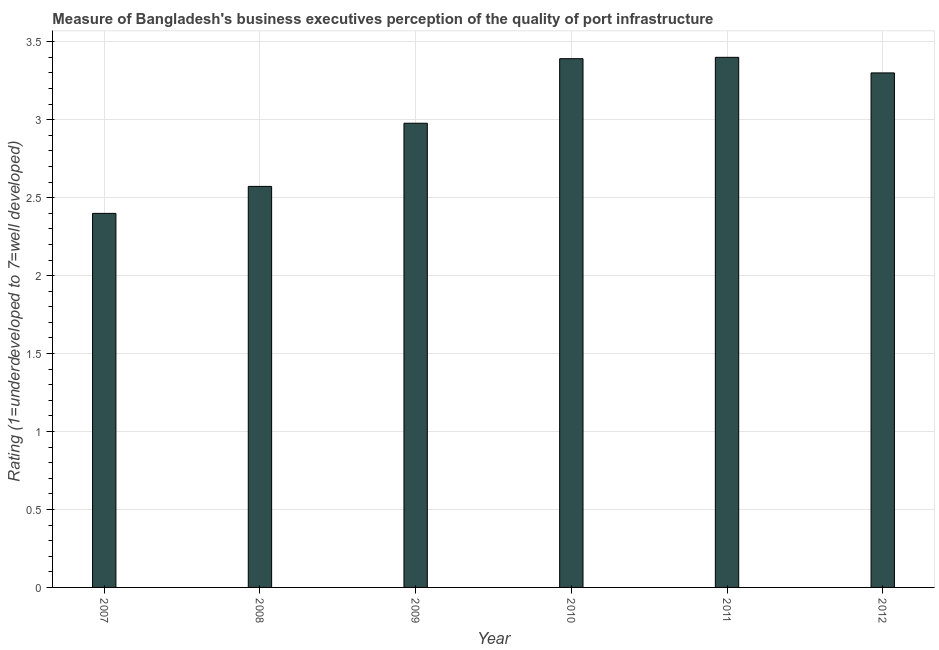Does the graph contain any zero values?
Offer a terse response. No. Does the graph contain grids?
Your answer should be compact. Yes. What is the title of the graph?
Provide a short and direct response. Measure of Bangladesh's business executives perception of the quality of port infrastructure. What is the label or title of the X-axis?
Provide a short and direct response. Year. What is the label or title of the Y-axis?
Offer a very short reply. Rating (1=underdeveloped to 7=well developed) . Across all years, what is the maximum rating measuring quality of port infrastructure?
Give a very brief answer. 3.4. Across all years, what is the minimum rating measuring quality of port infrastructure?
Offer a very short reply. 2.4. In which year was the rating measuring quality of port infrastructure maximum?
Your answer should be very brief. 2011. In which year was the rating measuring quality of port infrastructure minimum?
Your answer should be compact. 2007. What is the sum of the rating measuring quality of port infrastructure?
Your answer should be very brief. 18.04. What is the difference between the rating measuring quality of port infrastructure in 2007 and 2009?
Provide a succinct answer. -0.58. What is the average rating measuring quality of port infrastructure per year?
Your response must be concise. 3.01. What is the median rating measuring quality of port infrastructure?
Offer a very short reply. 3.14. In how many years, is the rating measuring quality of port infrastructure greater than 2.4 ?
Offer a terse response. 5. What is the ratio of the rating measuring quality of port infrastructure in 2009 to that in 2010?
Your answer should be compact. 0.88. Is the rating measuring quality of port infrastructure in 2008 less than that in 2009?
Make the answer very short. Yes. What is the difference between the highest and the second highest rating measuring quality of port infrastructure?
Provide a succinct answer. 0.01. How many bars are there?
Provide a short and direct response. 6. Are the values on the major ticks of Y-axis written in scientific E-notation?
Provide a short and direct response. No. What is the Rating (1=underdeveloped to 7=well developed)  in 2007?
Your answer should be very brief. 2.4. What is the Rating (1=underdeveloped to 7=well developed)  of 2008?
Provide a short and direct response. 2.57. What is the Rating (1=underdeveloped to 7=well developed)  of 2009?
Ensure brevity in your answer.  2.98. What is the Rating (1=underdeveloped to 7=well developed)  in 2010?
Make the answer very short. 3.39. What is the Rating (1=underdeveloped to 7=well developed)  in 2011?
Offer a very short reply. 3.4. What is the Rating (1=underdeveloped to 7=well developed)  in 2012?
Provide a succinct answer. 3.3. What is the difference between the Rating (1=underdeveloped to 7=well developed)  in 2007 and 2008?
Your answer should be very brief. -0.17. What is the difference between the Rating (1=underdeveloped to 7=well developed)  in 2007 and 2009?
Your response must be concise. -0.58. What is the difference between the Rating (1=underdeveloped to 7=well developed)  in 2007 and 2010?
Give a very brief answer. -0.99. What is the difference between the Rating (1=underdeveloped to 7=well developed)  in 2007 and 2011?
Provide a succinct answer. -1. What is the difference between the Rating (1=underdeveloped to 7=well developed)  in 2007 and 2012?
Provide a short and direct response. -0.9. What is the difference between the Rating (1=underdeveloped to 7=well developed)  in 2008 and 2009?
Your response must be concise. -0.41. What is the difference between the Rating (1=underdeveloped to 7=well developed)  in 2008 and 2010?
Offer a very short reply. -0.82. What is the difference between the Rating (1=underdeveloped to 7=well developed)  in 2008 and 2011?
Give a very brief answer. -0.83. What is the difference between the Rating (1=underdeveloped to 7=well developed)  in 2008 and 2012?
Your answer should be compact. -0.73. What is the difference between the Rating (1=underdeveloped to 7=well developed)  in 2009 and 2010?
Ensure brevity in your answer.  -0.41. What is the difference between the Rating (1=underdeveloped to 7=well developed)  in 2009 and 2011?
Your response must be concise. -0.42. What is the difference between the Rating (1=underdeveloped to 7=well developed)  in 2009 and 2012?
Your response must be concise. -0.32. What is the difference between the Rating (1=underdeveloped to 7=well developed)  in 2010 and 2011?
Provide a succinct answer. -0.01. What is the difference between the Rating (1=underdeveloped to 7=well developed)  in 2010 and 2012?
Offer a very short reply. 0.09. What is the difference between the Rating (1=underdeveloped to 7=well developed)  in 2011 and 2012?
Keep it short and to the point. 0.1. What is the ratio of the Rating (1=underdeveloped to 7=well developed)  in 2007 to that in 2008?
Your response must be concise. 0.93. What is the ratio of the Rating (1=underdeveloped to 7=well developed)  in 2007 to that in 2009?
Your response must be concise. 0.81. What is the ratio of the Rating (1=underdeveloped to 7=well developed)  in 2007 to that in 2010?
Provide a succinct answer. 0.71. What is the ratio of the Rating (1=underdeveloped to 7=well developed)  in 2007 to that in 2011?
Keep it short and to the point. 0.71. What is the ratio of the Rating (1=underdeveloped to 7=well developed)  in 2007 to that in 2012?
Keep it short and to the point. 0.73. What is the ratio of the Rating (1=underdeveloped to 7=well developed)  in 2008 to that in 2009?
Give a very brief answer. 0.86. What is the ratio of the Rating (1=underdeveloped to 7=well developed)  in 2008 to that in 2010?
Your answer should be very brief. 0.76. What is the ratio of the Rating (1=underdeveloped to 7=well developed)  in 2008 to that in 2011?
Your response must be concise. 0.76. What is the ratio of the Rating (1=underdeveloped to 7=well developed)  in 2008 to that in 2012?
Provide a succinct answer. 0.78. What is the ratio of the Rating (1=underdeveloped to 7=well developed)  in 2009 to that in 2010?
Your answer should be very brief. 0.88. What is the ratio of the Rating (1=underdeveloped to 7=well developed)  in 2009 to that in 2011?
Provide a short and direct response. 0.88. What is the ratio of the Rating (1=underdeveloped to 7=well developed)  in 2009 to that in 2012?
Give a very brief answer. 0.9. What is the ratio of the Rating (1=underdeveloped to 7=well developed)  in 2010 to that in 2011?
Offer a very short reply. 1. What is the ratio of the Rating (1=underdeveloped to 7=well developed)  in 2010 to that in 2012?
Make the answer very short. 1.03. What is the ratio of the Rating (1=underdeveloped to 7=well developed)  in 2011 to that in 2012?
Provide a succinct answer. 1.03. 